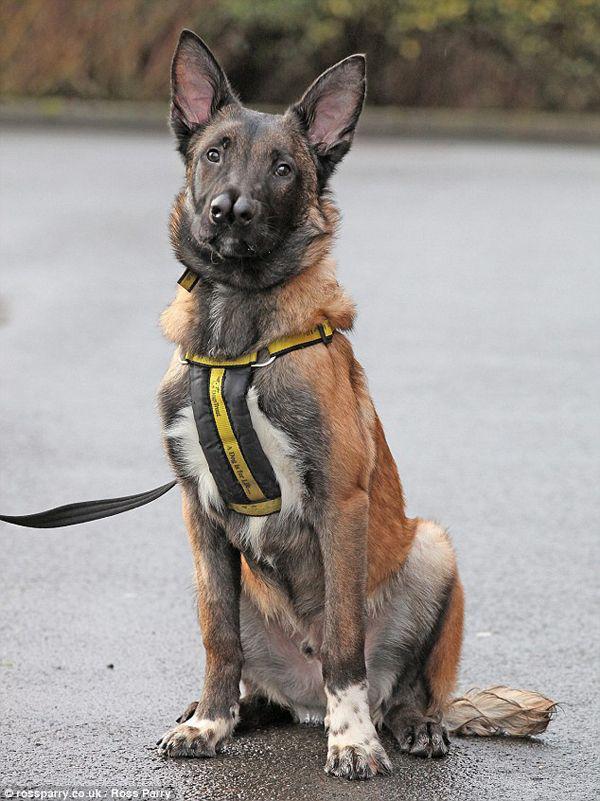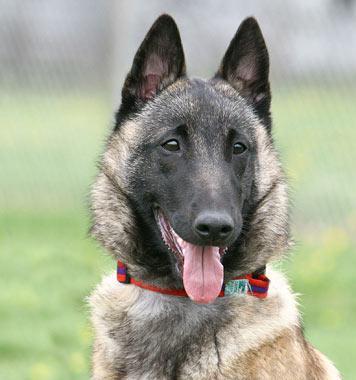The first image is the image on the left, the second image is the image on the right. Assess this claim about the two images: "One of the dogs has it's tongue hanging out and neither of the dogs is a puppy.". Correct or not? Answer yes or no. Yes. The first image is the image on the left, the second image is the image on the right. Analyze the images presented: Is the assertion "The image on the right features exactly two animals." valid? Answer yes or no. No. 